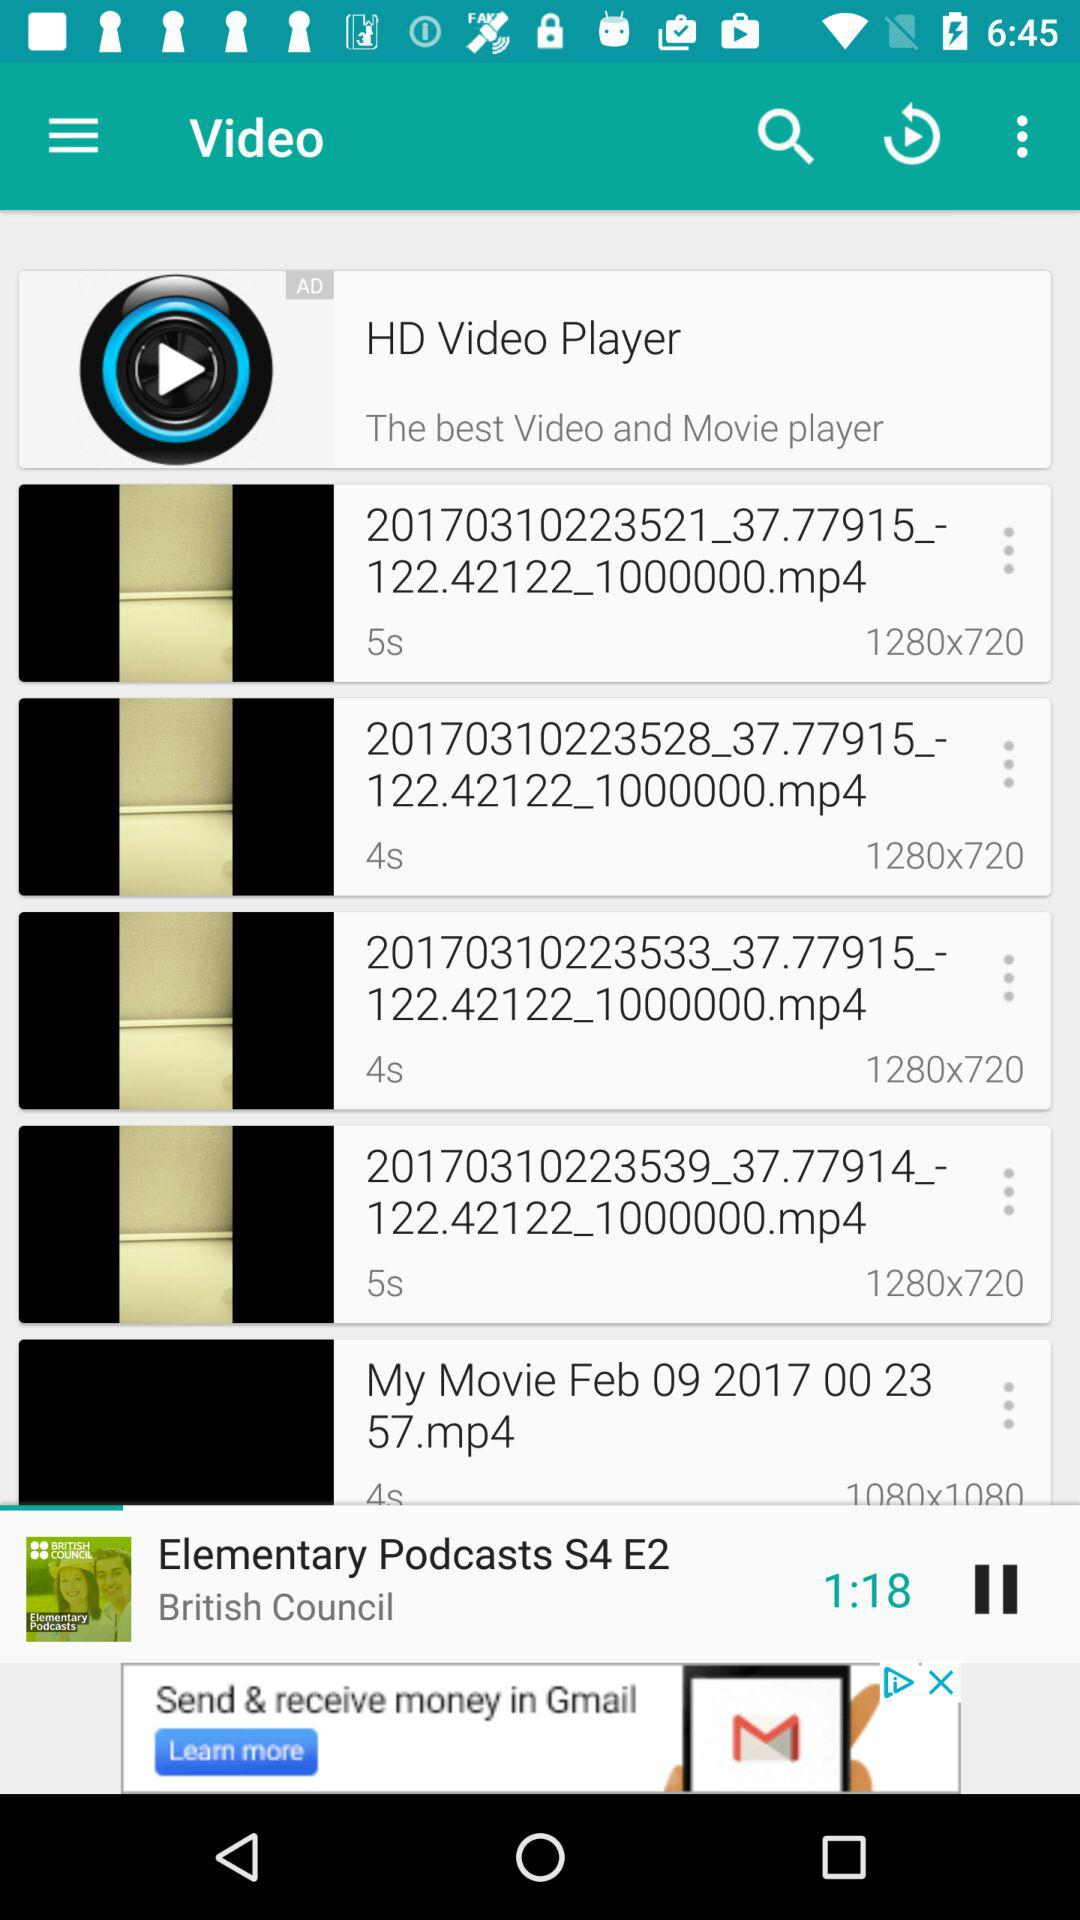How many video files are there?
Answer the question using a single word or phrase. 5 